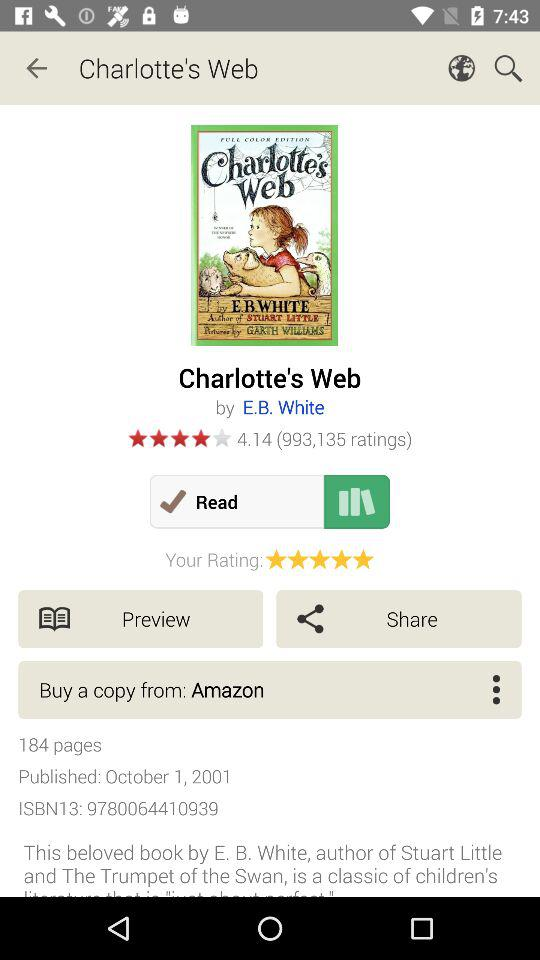What is the name of the book's author? The name of the book's author is E.B. White. 